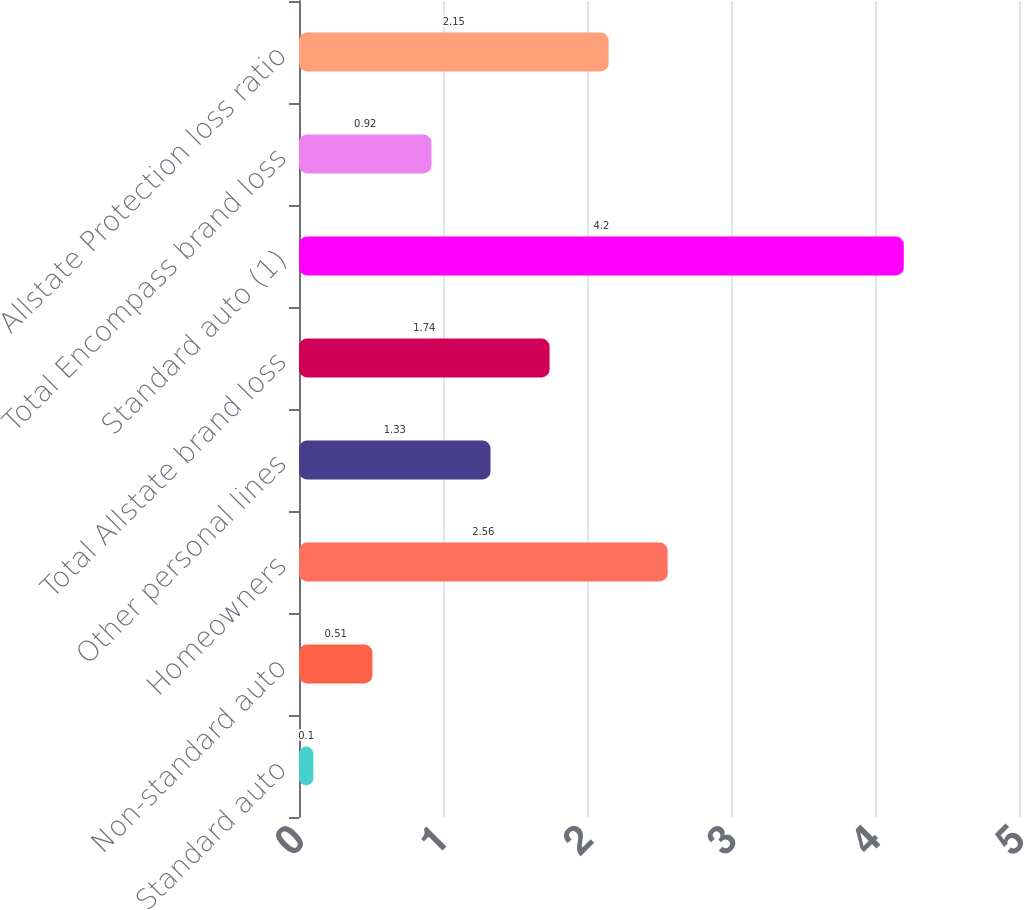Convert chart to OTSL. <chart><loc_0><loc_0><loc_500><loc_500><bar_chart><fcel>Standard auto<fcel>Non-standard auto<fcel>Homeowners<fcel>Other personal lines<fcel>Total Allstate brand loss<fcel>Standard auto (1)<fcel>Total Encompass brand loss<fcel>Allstate Protection loss ratio<nl><fcel>0.1<fcel>0.51<fcel>2.56<fcel>1.33<fcel>1.74<fcel>4.2<fcel>0.92<fcel>2.15<nl></chart> 